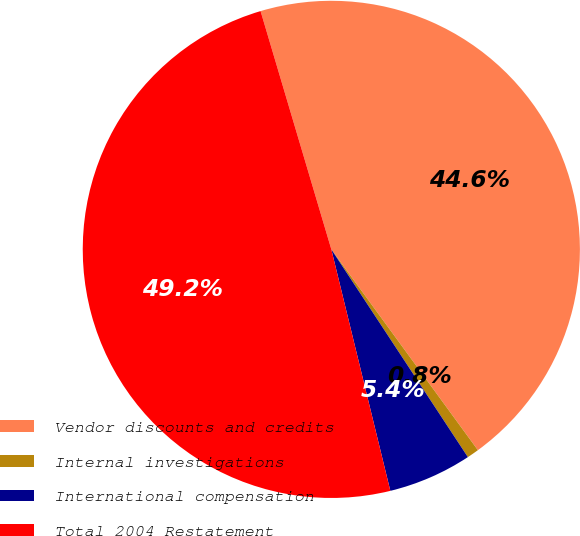<chart> <loc_0><loc_0><loc_500><loc_500><pie_chart><fcel>Vendor discounts and credits<fcel>Internal investigations<fcel>International compensation<fcel>Total 2004 Restatement<nl><fcel>44.56%<fcel>0.78%<fcel>5.44%<fcel>49.22%<nl></chart> 